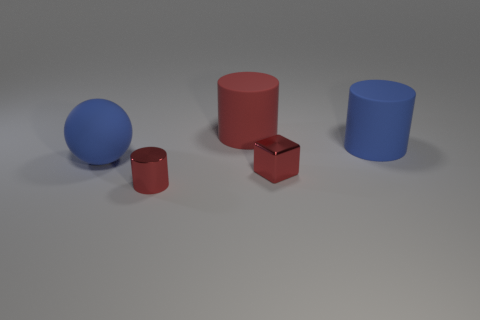What is the material of the large object that is the same color as the tiny cube?
Offer a terse response. Rubber. How many red objects have the same size as the metal cylinder?
Your response must be concise. 1. How many big objects are in front of the large blue object that is in front of the big blue thing to the right of the red metallic block?
Ensure brevity in your answer.  0. Is the number of red metallic cylinders behind the large sphere the same as the number of matte things that are in front of the big blue cylinder?
Provide a succinct answer. No. What number of tiny red metal objects have the same shape as the big red thing?
Offer a terse response. 1. Is there a object that has the same material as the red block?
Ensure brevity in your answer.  Yes. There is a tiny shiny object that is the same color as the metal cylinder; what is its shape?
Your answer should be very brief. Cube. How many tiny gray rubber cylinders are there?
Make the answer very short. 0. How many balls are small things or large objects?
Keep it short and to the point. 1. There is a matte cylinder that is the same size as the red matte object; what is its color?
Your answer should be very brief. Blue. 